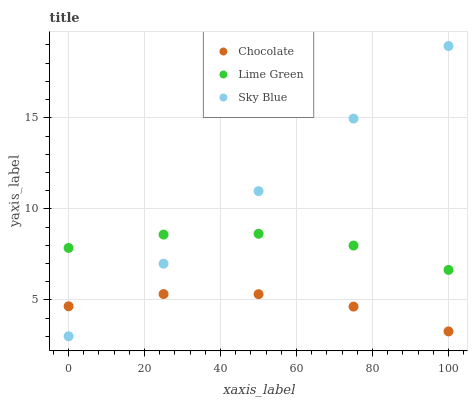Does Chocolate have the minimum area under the curve?
Answer yes or no. Yes. Does Sky Blue have the maximum area under the curve?
Answer yes or no. Yes. Does Lime Green have the minimum area under the curve?
Answer yes or no. No. Does Lime Green have the maximum area under the curve?
Answer yes or no. No. Is Sky Blue the smoothest?
Answer yes or no. Yes. Is Lime Green the roughest?
Answer yes or no. Yes. Is Chocolate the smoothest?
Answer yes or no. No. Is Chocolate the roughest?
Answer yes or no. No. Does Sky Blue have the lowest value?
Answer yes or no. Yes. Does Chocolate have the lowest value?
Answer yes or no. No. Does Sky Blue have the highest value?
Answer yes or no. Yes. Does Lime Green have the highest value?
Answer yes or no. No. Is Chocolate less than Lime Green?
Answer yes or no. Yes. Is Lime Green greater than Chocolate?
Answer yes or no. Yes. Does Sky Blue intersect Chocolate?
Answer yes or no. Yes. Is Sky Blue less than Chocolate?
Answer yes or no. No. Is Sky Blue greater than Chocolate?
Answer yes or no. No. Does Chocolate intersect Lime Green?
Answer yes or no. No. 